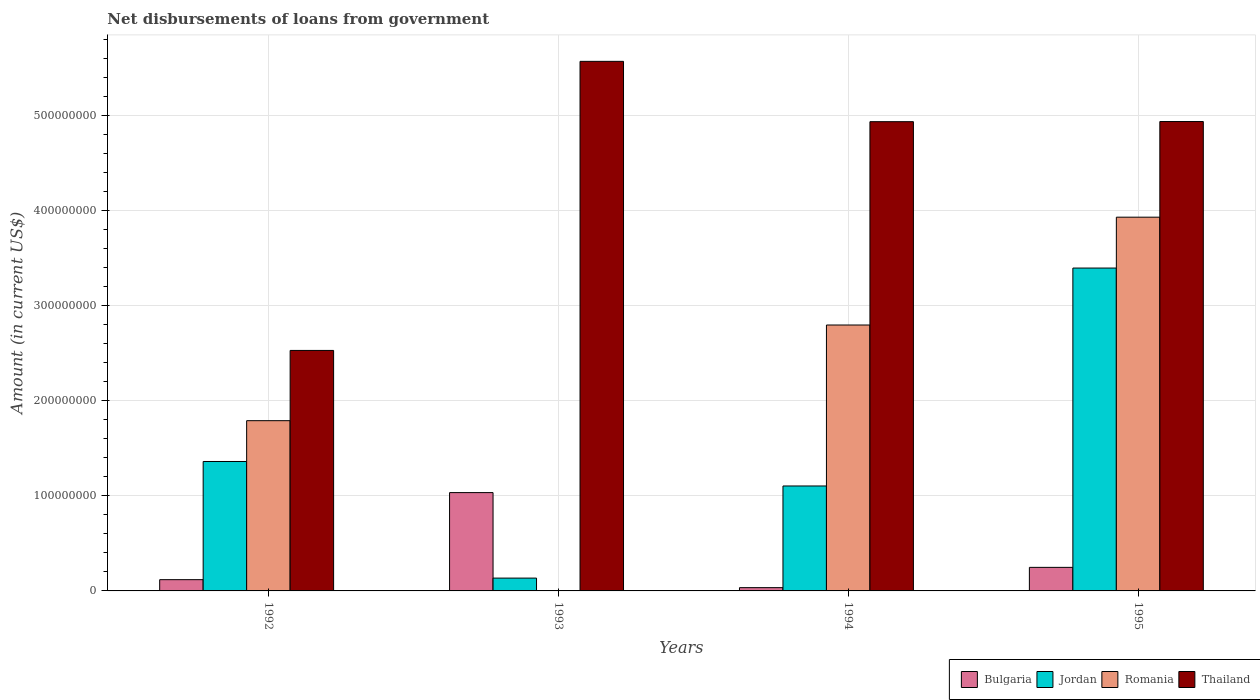How many different coloured bars are there?
Your answer should be very brief. 4. How many groups of bars are there?
Your response must be concise. 4. Are the number of bars per tick equal to the number of legend labels?
Offer a terse response. No. How many bars are there on the 4th tick from the left?
Make the answer very short. 4. How many bars are there on the 4th tick from the right?
Provide a short and direct response. 4. In how many cases, is the number of bars for a given year not equal to the number of legend labels?
Offer a very short reply. 1. What is the amount of loan disbursed from government in Thailand in 1993?
Offer a very short reply. 5.57e+08. Across all years, what is the maximum amount of loan disbursed from government in Bulgaria?
Provide a succinct answer. 1.03e+08. Across all years, what is the minimum amount of loan disbursed from government in Romania?
Provide a succinct answer. 0. What is the total amount of loan disbursed from government in Jordan in the graph?
Give a very brief answer. 6.00e+08. What is the difference between the amount of loan disbursed from government in Romania in 1992 and that in 1994?
Offer a terse response. -1.01e+08. What is the difference between the amount of loan disbursed from government in Romania in 1994 and the amount of loan disbursed from government in Jordan in 1995?
Offer a terse response. -5.99e+07. What is the average amount of loan disbursed from government in Jordan per year?
Keep it short and to the point. 1.50e+08. In the year 1995, what is the difference between the amount of loan disbursed from government in Romania and amount of loan disbursed from government in Thailand?
Make the answer very short. -1.01e+08. What is the ratio of the amount of loan disbursed from government in Jordan in 1994 to that in 1995?
Give a very brief answer. 0.33. Is the amount of loan disbursed from government in Bulgaria in 1994 less than that in 1995?
Ensure brevity in your answer.  Yes. Is the difference between the amount of loan disbursed from government in Romania in 1992 and 1995 greater than the difference between the amount of loan disbursed from government in Thailand in 1992 and 1995?
Ensure brevity in your answer.  Yes. What is the difference between the highest and the second highest amount of loan disbursed from government in Romania?
Offer a terse response. 1.13e+08. What is the difference between the highest and the lowest amount of loan disbursed from government in Bulgaria?
Provide a short and direct response. 1.00e+08. In how many years, is the amount of loan disbursed from government in Thailand greater than the average amount of loan disbursed from government in Thailand taken over all years?
Offer a terse response. 3. Is it the case that in every year, the sum of the amount of loan disbursed from government in Thailand and amount of loan disbursed from government in Romania is greater than the sum of amount of loan disbursed from government in Jordan and amount of loan disbursed from government in Bulgaria?
Give a very brief answer. No. Is it the case that in every year, the sum of the amount of loan disbursed from government in Thailand and amount of loan disbursed from government in Bulgaria is greater than the amount of loan disbursed from government in Jordan?
Provide a succinct answer. Yes. How many years are there in the graph?
Make the answer very short. 4. Does the graph contain any zero values?
Provide a succinct answer. Yes. Does the graph contain grids?
Your response must be concise. Yes. Where does the legend appear in the graph?
Offer a very short reply. Bottom right. How many legend labels are there?
Your answer should be very brief. 4. How are the legend labels stacked?
Provide a short and direct response. Horizontal. What is the title of the graph?
Your answer should be very brief. Net disbursements of loans from government. What is the label or title of the X-axis?
Your answer should be very brief. Years. What is the label or title of the Y-axis?
Provide a short and direct response. Amount (in current US$). What is the Amount (in current US$) in Bulgaria in 1992?
Offer a terse response. 1.18e+07. What is the Amount (in current US$) of Jordan in 1992?
Ensure brevity in your answer.  1.36e+08. What is the Amount (in current US$) in Romania in 1992?
Provide a succinct answer. 1.79e+08. What is the Amount (in current US$) in Thailand in 1992?
Give a very brief answer. 2.53e+08. What is the Amount (in current US$) in Bulgaria in 1993?
Offer a very short reply. 1.03e+08. What is the Amount (in current US$) in Jordan in 1993?
Ensure brevity in your answer.  1.35e+07. What is the Amount (in current US$) of Romania in 1993?
Your answer should be compact. 0. What is the Amount (in current US$) in Thailand in 1993?
Your response must be concise. 5.57e+08. What is the Amount (in current US$) of Bulgaria in 1994?
Make the answer very short. 3.44e+06. What is the Amount (in current US$) in Jordan in 1994?
Your answer should be compact. 1.10e+08. What is the Amount (in current US$) of Romania in 1994?
Your response must be concise. 2.80e+08. What is the Amount (in current US$) in Thailand in 1994?
Your answer should be compact. 4.94e+08. What is the Amount (in current US$) of Bulgaria in 1995?
Give a very brief answer. 2.48e+07. What is the Amount (in current US$) in Jordan in 1995?
Give a very brief answer. 3.40e+08. What is the Amount (in current US$) of Romania in 1995?
Give a very brief answer. 3.93e+08. What is the Amount (in current US$) in Thailand in 1995?
Your answer should be compact. 4.94e+08. Across all years, what is the maximum Amount (in current US$) of Bulgaria?
Offer a very short reply. 1.03e+08. Across all years, what is the maximum Amount (in current US$) of Jordan?
Provide a short and direct response. 3.40e+08. Across all years, what is the maximum Amount (in current US$) in Romania?
Offer a very short reply. 3.93e+08. Across all years, what is the maximum Amount (in current US$) of Thailand?
Keep it short and to the point. 5.57e+08. Across all years, what is the minimum Amount (in current US$) of Bulgaria?
Offer a terse response. 3.44e+06. Across all years, what is the minimum Amount (in current US$) of Jordan?
Your answer should be very brief. 1.35e+07. Across all years, what is the minimum Amount (in current US$) in Thailand?
Offer a terse response. 2.53e+08. What is the total Amount (in current US$) of Bulgaria in the graph?
Provide a short and direct response. 1.44e+08. What is the total Amount (in current US$) in Jordan in the graph?
Offer a terse response. 6.00e+08. What is the total Amount (in current US$) in Romania in the graph?
Your answer should be compact. 8.52e+08. What is the total Amount (in current US$) in Thailand in the graph?
Provide a succinct answer. 1.80e+09. What is the difference between the Amount (in current US$) in Bulgaria in 1992 and that in 1993?
Keep it short and to the point. -9.16e+07. What is the difference between the Amount (in current US$) in Jordan in 1992 and that in 1993?
Give a very brief answer. 1.23e+08. What is the difference between the Amount (in current US$) in Thailand in 1992 and that in 1993?
Make the answer very short. -3.04e+08. What is the difference between the Amount (in current US$) of Bulgaria in 1992 and that in 1994?
Your answer should be very brief. 8.41e+06. What is the difference between the Amount (in current US$) of Jordan in 1992 and that in 1994?
Offer a terse response. 2.58e+07. What is the difference between the Amount (in current US$) of Romania in 1992 and that in 1994?
Offer a terse response. -1.01e+08. What is the difference between the Amount (in current US$) of Thailand in 1992 and that in 1994?
Give a very brief answer. -2.41e+08. What is the difference between the Amount (in current US$) in Bulgaria in 1992 and that in 1995?
Make the answer very short. -1.29e+07. What is the difference between the Amount (in current US$) in Jordan in 1992 and that in 1995?
Your answer should be compact. -2.04e+08. What is the difference between the Amount (in current US$) of Romania in 1992 and that in 1995?
Provide a short and direct response. -2.14e+08. What is the difference between the Amount (in current US$) in Thailand in 1992 and that in 1995?
Provide a short and direct response. -2.41e+08. What is the difference between the Amount (in current US$) in Bulgaria in 1993 and that in 1994?
Make the answer very short. 1.00e+08. What is the difference between the Amount (in current US$) of Jordan in 1993 and that in 1994?
Offer a very short reply. -9.69e+07. What is the difference between the Amount (in current US$) in Thailand in 1993 and that in 1994?
Keep it short and to the point. 6.35e+07. What is the difference between the Amount (in current US$) in Bulgaria in 1993 and that in 1995?
Make the answer very short. 7.87e+07. What is the difference between the Amount (in current US$) of Jordan in 1993 and that in 1995?
Offer a terse response. -3.26e+08. What is the difference between the Amount (in current US$) in Thailand in 1993 and that in 1995?
Your answer should be very brief. 6.33e+07. What is the difference between the Amount (in current US$) in Bulgaria in 1994 and that in 1995?
Your response must be concise. -2.14e+07. What is the difference between the Amount (in current US$) of Jordan in 1994 and that in 1995?
Your answer should be very brief. -2.29e+08. What is the difference between the Amount (in current US$) in Romania in 1994 and that in 1995?
Make the answer very short. -1.13e+08. What is the difference between the Amount (in current US$) in Thailand in 1994 and that in 1995?
Offer a very short reply. -1.41e+05. What is the difference between the Amount (in current US$) of Bulgaria in 1992 and the Amount (in current US$) of Jordan in 1993?
Provide a succinct answer. -1.64e+06. What is the difference between the Amount (in current US$) of Bulgaria in 1992 and the Amount (in current US$) of Thailand in 1993?
Your answer should be compact. -5.45e+08. What is the difference between the Amount (in current US$) of Jordan in 1992 and the Amount (in current US$) of Thailand in 1993?
Your response must be concise. -4.21e+08. What is the difference between the Amount (in current US$) in Romania in 1992 and the Amount (in current US$) in Thailand in 1993?
Make the answer very short. -3.78e+08. What is the difference between the Amount (in current US$) in Bulgaria in 1992 and the Amount (in current US$) in Jordan in 1994?
Offer a terse response. -9.86e+07. What is the difference between the Amount (in current US$) in Bulgaria in 1992 and the Amount (in current US$) in Romania in 1994?
Offer a very short reply. -2.68e+08. What is the difference between the Amount (in current US$) in Bulgaria in 1992 and the Amount (in current US$) in Thailand in 1994?
Keep it short and to the point. -4.82e+08. What is the difference between the Amount (in current US$) in Jordan in 1992 and the Amount (in current US$) in Romania in 1994?
Make the answer very short. -1.44e+08. What is the difference between the Amount (in current US$) in Jordan in 1992 and the Amount (in current US$) in Thailand in 1994?
Offer a very short reply. -3.58e+08. What is the difference between the Amount (in current US$) of Romania in 1992 and the Amount (in current US$) of Thailand in 1994?
Offer a terse response. -3.15e+08. What is the difference between the Amount (in current US$) of Bulgaria in 1992 and the Amount (in current US$) of Jordan in 1995?
Make the answer very short. -3.28e+08. What is the difference between the Amount (in current US$) in Bulgaria in 1992 and the Amount (in current US$) in Romania in 1995?
Keep it short and to the point. -3.81e+08. What is the difference between the Amount (in current US$) of Bulgaria in 1992 and the Amount (in current US$) of Thailand in 1995?
Offer a very short reply. -4.82e+08. What is the difference between the Amount (in current US$) of Jordan in 1992 and the Amount (in current US$) of Romania in 1995?
Make the answer very short. -2.57e+08. What is the difference between the Amount (in current US$) in Jordan in 1992 and the Amount (in current US$) in Thailand in 1995?
Ensure brevity in your answer.  -3.58e+08. What is the difference between the Amount (in current US$) of Romania in 1992 and the Amount (in current US$) of Thailand in 1995?
Provide a short and direct response. -3.15e+08. What is the difference between the Amount (in current US$) in Bulgaria in 1993 and the Amount (in current US$) in Jordan in 1994?
Provide a succinct answer. -6.98e+06. What is the difference between the Amount (in current US$) in Bulgaria in 1993 and the Amount (in current US$) in Romania in 1994?
Offer a very short reply. -1.76e+08. What is the difference between the Amount (in current US$) in Bulgaria in 1993 and the Amount (in current US$) in Thailand in 1994?
Offer a very short reply. -3.90e+08. What is the difference between the Amount (in current US$) in Jordan in 1993 and the Amount (in current US$) in Romania in 1994?
Ensure brevity in your answer.  -2.66e+08. What is the difference between the Amount (in current US$) in Jordan in 1993 and the Amount (in current US$) in Thailand in 1994?
Provide a short and direct response. -4.80e+08. What is the difference between the Amount (in current US$) of Bulgaria in 1993 and the Amount (in current US$) of Jordan in 1995?
Give a very brief answer. -2.36e+08. What is the difference between the Amount (in current US$) of Bulgaria in 1993 and the Amount (in current US$) of Romania in 1995?
Offer a very short reply. -2.90e+08. What is the difference between the Amount (in current US$) of Bulgaria in 1993 and the Amount (in current US$) of Thailand in 1995?
Provide a short and direct response. -3.90e+08. What is the difference between the Amount (in current US$) of Jordan in 1993 and the Amount (in current US$) of Romania in 1995?
Offer a very short reply. -3.80e+08. What is the difference between the Amount (in current US$) of Jordan in 1993 and the Amount (in current US$) of Thailand in 1995?
Make the answer very short. -4.80e+08. What is the difference between the Amount (in current US$) of Bulgaria in 1994 and the Amount (in current US$) of Jordan in 1995?
Make the answer very short. -3.36e+08. What is the difference between the Amount (in current US$) of Bulgaria in 1994 and the Amount (in current US$) of Romania in 1995?
Your answer should be very brief. -3.90e+08. What is the difference between the Amount (in current US$) of Bulgaria in 1994 and the Amount (in current US$) of Thailand in 1995?
Your answer should be compact. -4.90e+08. What is the difference between the Amount (in current US$) of Jordan in 1994 and the Amount (in current US$) of Romania in 1995?
Ensure brevity in your answer.  -2.83e+08. What is the difference between the Amount (in current US$) of Jordan in 1994 and the Amount (in current US$) of Thailand in 1995?
Give a very brief answer. -3.83e+08. What is the difference between the Amount (in current US$) in Romania in 1994 and the Amount (in current US$) in Thailand in 1995?
Make the answer very short. -2.14e+08. What is the average Amount (in current US$) of Bulgaria per year?
Provide a succinct answer. 3.59e+07. What is the average Amount (in current US$) in Jordan per year?
Make the answer very short. 1.50e+08. What is the average Amount (in current US$) of Romania per year?
Give a very brief answer. 2.13e+08. What is the average Amount (in current US$) in Thailand per year?
Make the answer very short. 4.49e+08. In the year 1992, what is the difference between the Amount (in current US$) in Bulgaria and Amount (in current US$) in Jordan?
Offer a very short reply. -1.24e+08. In the year 1992, what is the difference between the Amount (in current US$) in Bulgaria and Amount (in current US$) in Romania?
Give a very brief answer. -1.67e+08. In the year 1992, what is the difference between the Amount (in current US$) of Bulgaria and Amount (in current US$) of Thailand?
Offer a terse response. -2.41e+08. In the year 1992, what is the difference between the Amount (in current US$) in Jordan and Amount (in current US$) in Romania?
Provide a short and direct response. -4.29e+07. In the year 1992, what is the difference between the Amount (in current US$) in Jordan and Amount (in current US$) in Thailand?
Provide a succinct answer. -1.17e+08. In the year 1992, what is the difference between the Amount (in current US$) in Romania and Amount (in current US$) in Thailand?
Offer a very short reply. -7.39e+07. In the year 1993, what is the difference between the Amount (in current US$) of Bulgaria and Amount (in current US$) of Jordan?
Provide a succinct answer. 9.00e+07. In the year 1993, what is the difference between the Amount (in current US$) in Bulgaria and Amount (in current US$) in Thailand?
Give a very brief answer. -4.54e+08. In the year 1993, what is the difference between the Amount (in current US$) in Jordan and Amount (in current US$) in Thailand?
Offer a terse response. -5.44e+08. In the year 1994, what is the difference between the Amount (in current US$) in Bulgaria and Amount (in current US$) in Jordan?
Keep it short and to the point. -1.07e+08. In the year 1994, what is the difference between the Amount (in current US$) in Bulgaria and Amount (in current US$) in Romania?
Your response must be concise. -2.76e+08. In the year 1994, what is the difference between the Amount (in current US$) in Bulgaria and Amount (in current US$) in Thailand?
Your answer should be compact. -4.90e+08. In the year 1994, what is the difference between the Amount (in current US$) in Jordan and Amount (in current US$) in Romania?
Provide a succinct answer. -1.69e+08. In the year 1994, what is the difference between the Amount (in current US$) of Jordan and Amount (in current US$) of Thailand?
Your answer should be compact. -3.83e+08. In the year 1994, what is the difference between the Amount (in current US$) in Romania and Amount (in current US$) in Thailand?
Your answer should be compact. -2.14e+08. In the year 1995, what is the difference between the Amount (in current US$) in Bulgaria and Amount (in current US$) in Jordan?
Ensure brevity in your answer.  -3.15e+08. In the year 1995, what is the difference between the Amount (in current US$) in Bulgaria and Amount (in current US$) in Romania?
Offer a terse response. -3.68e+08. In the year 1995, what is the difference between the Amount (in current US$) of Bulgaria and Amount (in current US$) of Thailand?
Your response must be concise. -4.69e+08. In the year 1995, what is the difference between the Amount (in current US$) in Jordan and Amount (in current US$) in Romania?
Offer a terse response. -5.35e+07. In the year 1995, what is the difference between the Amount (in current US$) in Jordan and Amount (in current US$) in Thailand?
Provide a short and direct response. -1.54e+08. In the year 1995, what is the difference between the Amount (in current US$) in Romania and Amount (in current US$) in Thailand?
Your answer should be compact. -1.01e+08. What is the ratio of the Amount (in current US$) in Bulgaria in 1992 to that in 1993?
Keep it short and to the point. 0.11. What is the ratio of the Amount (in current US$) in Jordan in 1992 to that in 1993?
Your answer should be very brief. 10.1. What is the ratio of the Amount (in current US$) of Thailand in 1992 to that in 1993?
Provide a succinct answer. 0.45. What is the ratio of the Amount (in current US$) in Bulgaria in 1992 to that in 1994?
Ensure brevity in your answer.  3.45. What is the ratio of the Amount (in current US$) in Jordan in 1992 to that in 1994?
Make the answer very short. 1.23. What is the ratio of the Amount (in current US$) of Romania in 1992 to that in 1994?
Your answer should be very brief. 0.64. What is the ratio of the Amount (in current US$) in Thailand in 1992 to that in 1994?
Keep it short and to the point. 0.51. What is the ratio of the Amount (in current US$) in Bulgaria in 1992 to that in 1995?
Your answer should be very brief. 0.48. What is the ratio of the Amount (in current US$) of Jordan in 1992 to that in 1995?
Provide a succinct answer. 0.4. What is the ratio of the Amount (in current US$) of Romania in 1992 to that in 1995?
Offer a terse response. 0.46. What is the ratio of the Amount (in current US$) in Thailand in 1992 to that in 1995?
Make the answer very short. 0.51. What is the ratio of the Amount (in current US$) of Bulgaria in 1993 to that in 1994?
Your response must be concise. 30.1. What is the ratio of the Amount (in current US$) in Jordan in 1993 to that in 1994?
Your answer should be very brief. 0.12. What is the ratio of the Amount (in current US$) of Thailand in 1993 to that in 1994?
Your response must be concise. 1.13. What is the ratio of the Amount (in current US$) in Bulgaria in 1993 to that in 1995?
Offer a very short reply. 4.17. What is the ratio of the Amount (in current US$) of Jordan in 1993 to that in 1995?
Make the answer very short. 0.04. What is the ratio of the Amount (in current US$) in Thailand in 1993 to that in 1995?
Keep it short and to the point. 1.13. What is the ratio of the Amount (in current US$) in Bulgaria in 1994 to that in 1995?
Your answer should be compact. 0.14. What is the ratio of the Amount (in current US$) in Jordan in 1994 to that in 1995?
Offer a terse response. 0.33. What is the ratio of the Amount (in current US$) in Romania in 1994 to that in 1995?
Keep it short and to the point. 0.71. What is the difference between the highest and the second highest Amount (in current US$) of Bulgaria?
Keep it short and to the point. 7.87e+07. What is the difference between the highest and the second highest Amount (in current US$) in Jordan?
Provide a succinct answer. 2.04e+08. What is the difference between the highest and the second highest Amount (in current US$) in Romania?
Your answer should be compact. 1.13e+08. What is the difference between the highest and the second highest Amount (in current US$) of Thailand?
Keep it short and to the point. 6.33e+07. What is the difference between the highest and the lowest Amount (in current US$) of Bulgaria?
Keep it short and to the point. 1.00e+08. What is the difference between the highest and the lowest Amount (in current US$) of Jordan?
Your response must be concise. 3.26e+08. What is the difference between the highest and the lowest Amount (in current US$) of Romania?
Your response must be concise. 3.93e+08. What is the difference between the highest and the lowest Amount (in current US$) of Thailand?
Offer a terse response. 3.04e+08. 